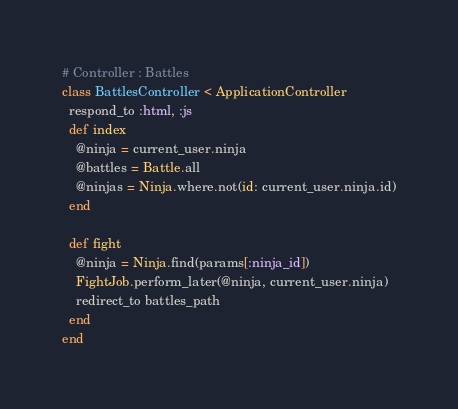Convert code to text. <code><loc_0><loc_0><loc_500><loc_500><_Ruby_># Controller : Battles
class BattlesController < ApplicationController
  respond_to :html, :js
  def index
    @ninja = current_user.ninja
    @battles = Battle.all
    @ninjas = Ninja.where.not(id: current_user.ninja.id)
  end

  def fight
    @ninja = Ninja.find(params[:ninja_id])
    FightJob.perform_later(@ninja, current_user.ninja)
    redirect_to battles_path
  end
end
</code> 